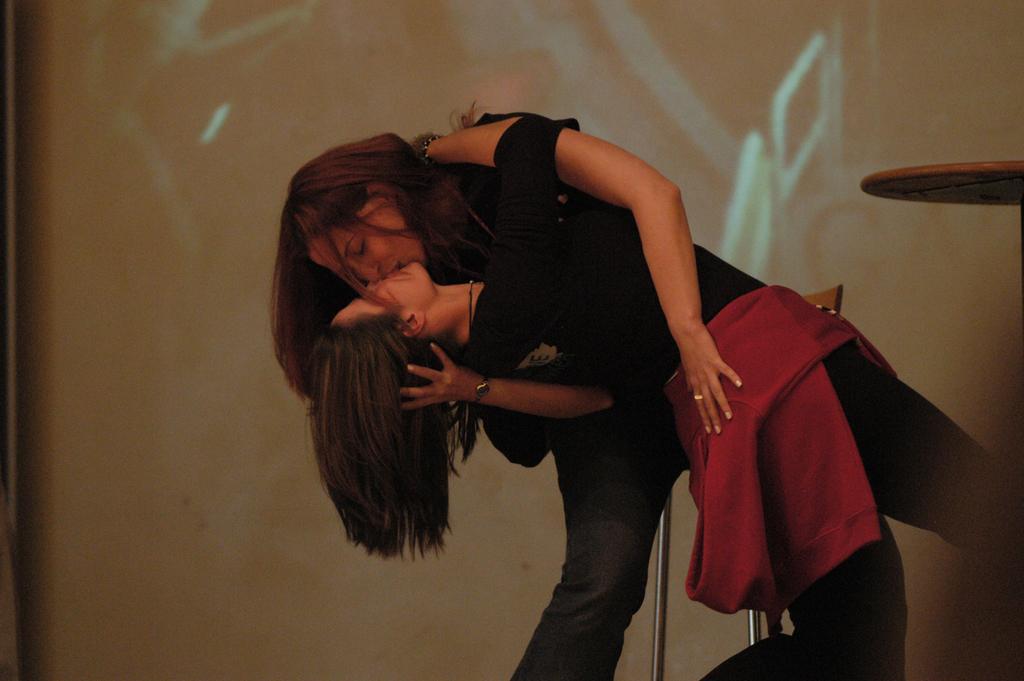Can you describe this image briefly? In this image I can see two people with black and red color dresses. To the right I can see the table. In the back there is a screen. 